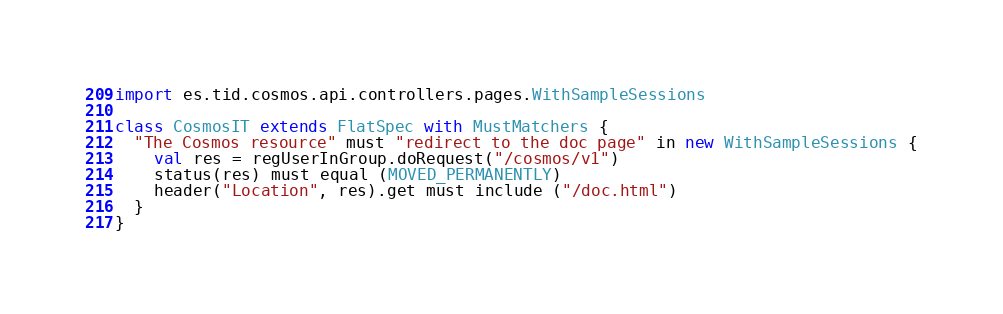<code> <loc_0><loc_0><loc_500><loc_500><_Scala_>import es.tid.cosmos.api.controllers.pages.WithSampleSessions

class CosmosIT extends FlatSpec with MustMatchers {
  "The Cosmos resource" must "redirect to the doc page" in new WithSampleSessions {
    val res = regUserInGroup.doRequest("/cosmos/v1")
    status(res) must equal (MOVED_PERMANENTLY)
    header("Location", res).get must include ("/doc.html")
  }
}
</code> 